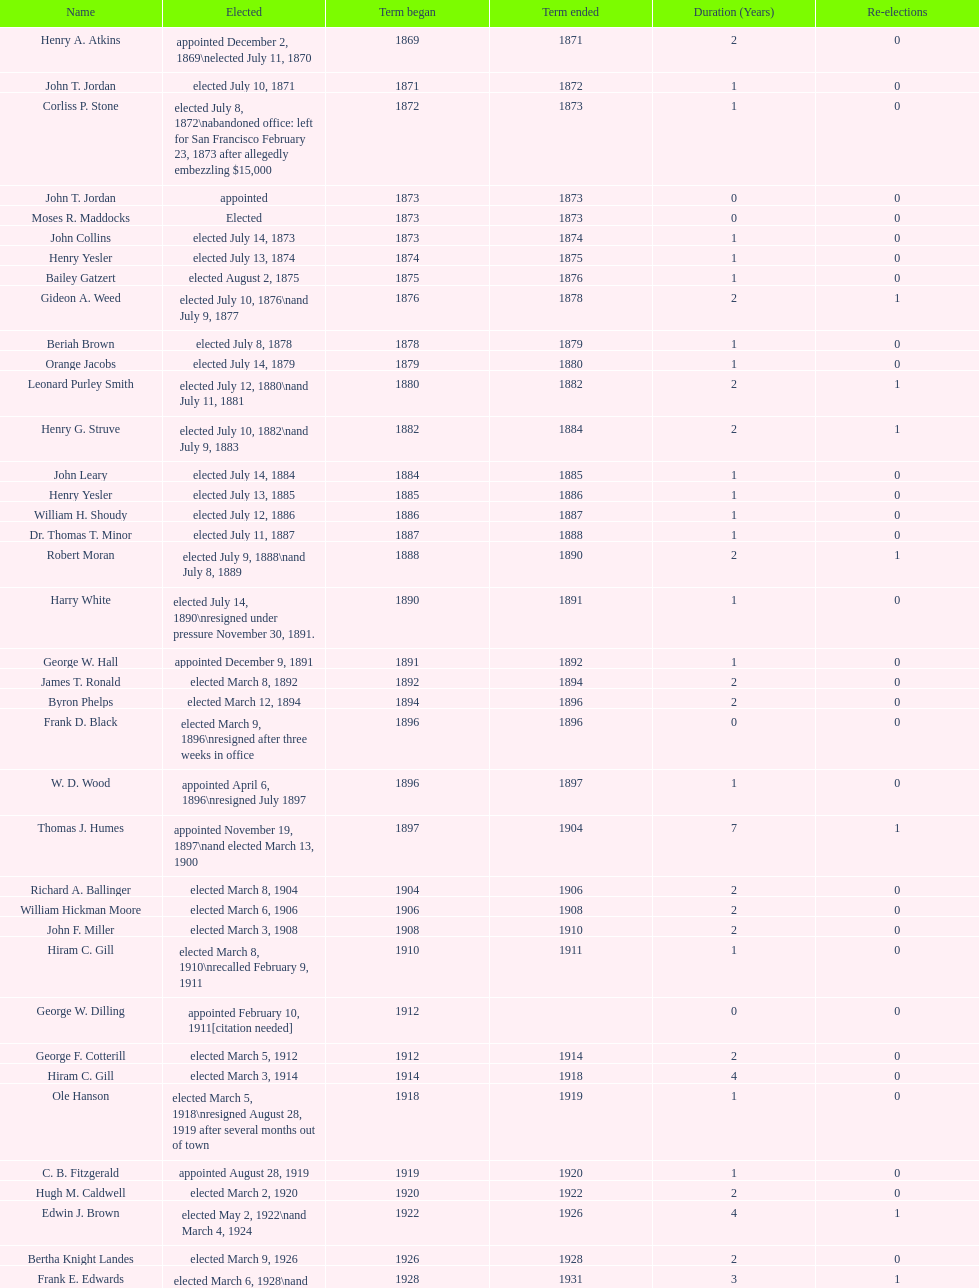Who served as the first mayor during the 1900s? Richard A. Ballinger. 